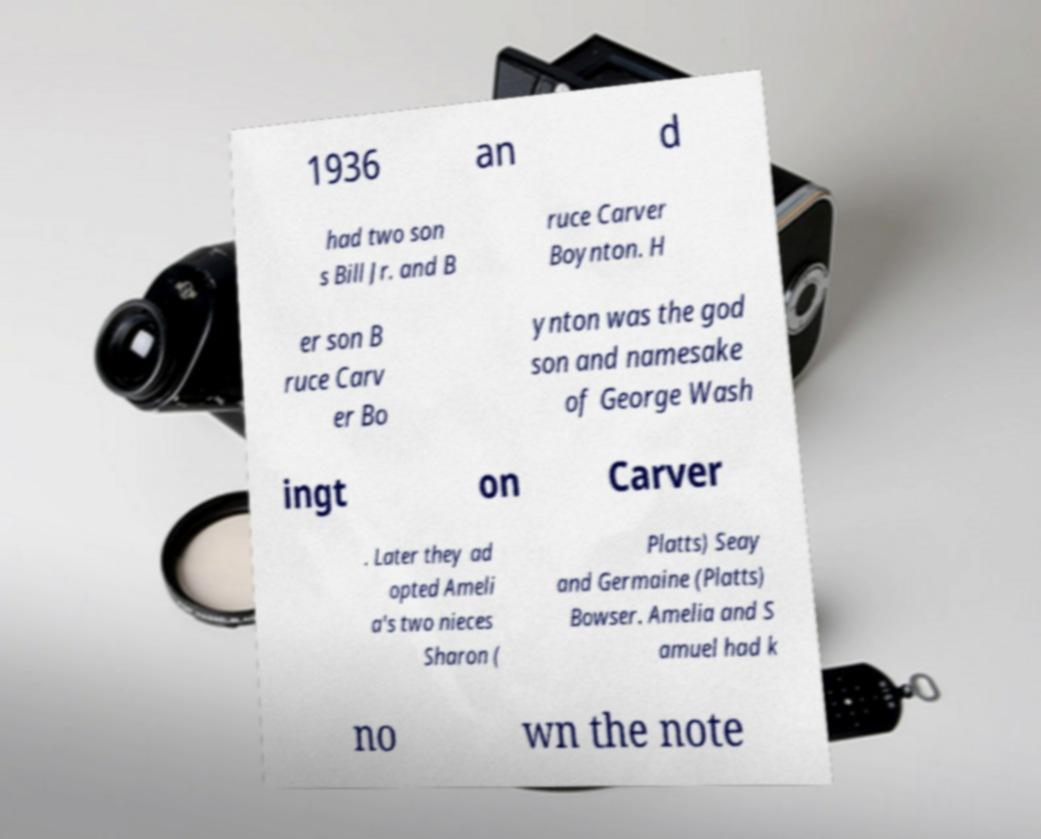Please read and relay the text visible in this image. What does it say? 1936 an d had two son s Bill Jr. and B ruce Carver Boynton. H er son B ruce Carv er Bo ynton was the god son and namesake of George Wash ingt on Carver . Later they ad opted Ameli a's two nieces Sharon ( Platts) Seay and Germaine (Platts) Bowser. Amelia and S amuel had k no wn the note 